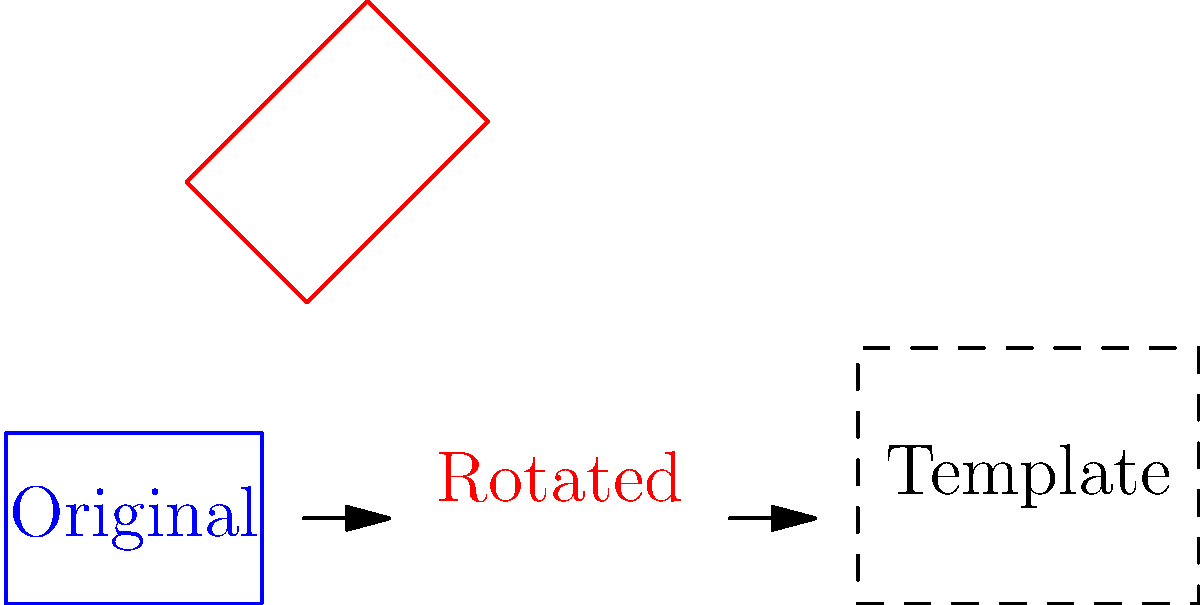A photographer's website template requires images to be rotated 45 degrees and resized to fit a 4:3 aspect ratio. Given an original image of 3x2 units, what should be the dimensions of the rotated and resized image to fit the template while maintaining its aspect ratio? To solve this problem, we need to follow these steps:

1. Rotate the image by 45 degrees.
2. Calculate the new dimensions after rotation.
3. Resize the rotated image to fit the 4:3 aspect ratio.

Step 1: Rotation
The image is rotated 45 degrees. This doesn't change its dimensions yet.

Step 2: Calculate new dimensions after rotation
The diagonal of the original image becomes the width of the rotated image.
Diagonal = $\sqrt{3^2 + 2^2} = \sqrt{13}$ units

So, the rotated image dimensions are $\sqrt{13} \times \sqrt{13}$ units.

Step 3: Resize to fit 4:3 aspect ratio
We need to scale the rotated image to fit a 4:3 aspect ratio. Let's say the new width is 4x and the new height is 3x.

To maintain the aspect ratio:
$\frac{4x}{3x} = \frac{\sqrt{13}}{\sqrt{13}} = 1$

This means the rotated and resized image should have dimensions of 4x and 3x units, where x is a scaling factor.

To find x, we can use the area of the original image:
Original area = $3 \times 2 = 6$ square units

New area should be the same:
$4x \times 3x = 12x^2 = 6$
$x^2 = \frac{1}{2}$
$x = \frac{1}{\sqrt{2}}$

Therefore, the final dimensions are:
Width = $4 \times \frac{1}{\sqrt{2}} = \frac{4}{\sqrt{2}} = 2\sqrt{2}$ units
Height = $3 \times \frac{1}{\sqrt{2}} = \frac{3}{\sqrt{2}}$ units
Answer: $2\sqrt{2} \times \frac{3}{\sqrt{2}}$ units 